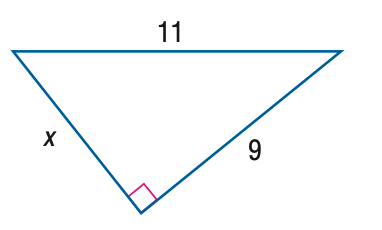Answer the mathemtical geometry problem and directly provide the correct option letter.
Question: Find x.
Choices: A: 5 B: 2 \sqrt { 10 } C: 7 D: \sqrt { 202 } B 